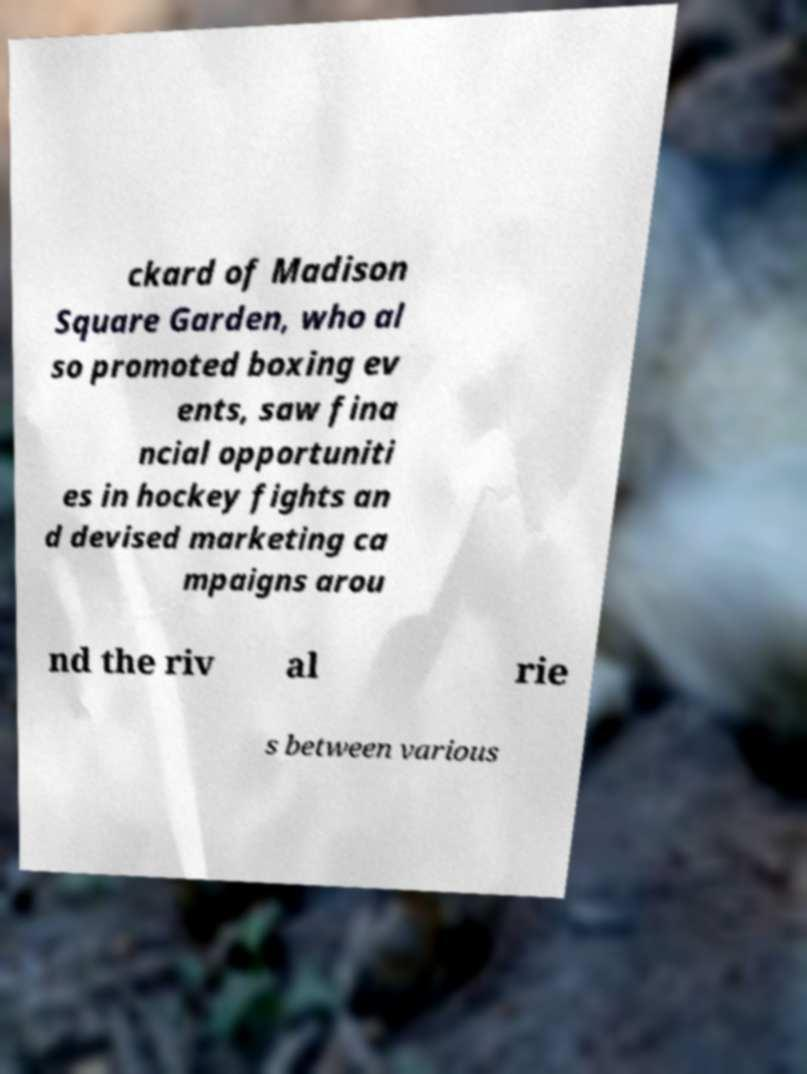There's text embedded in this image that I need extracted. Can you transcribe it verbatim? ckard of Madison Square Garden, who al so promoted boxing ev ents, saw fina ncial opportuniti es in hockey fights an d devised marketing ca mpaigns arou nd the riv al rie s between various 